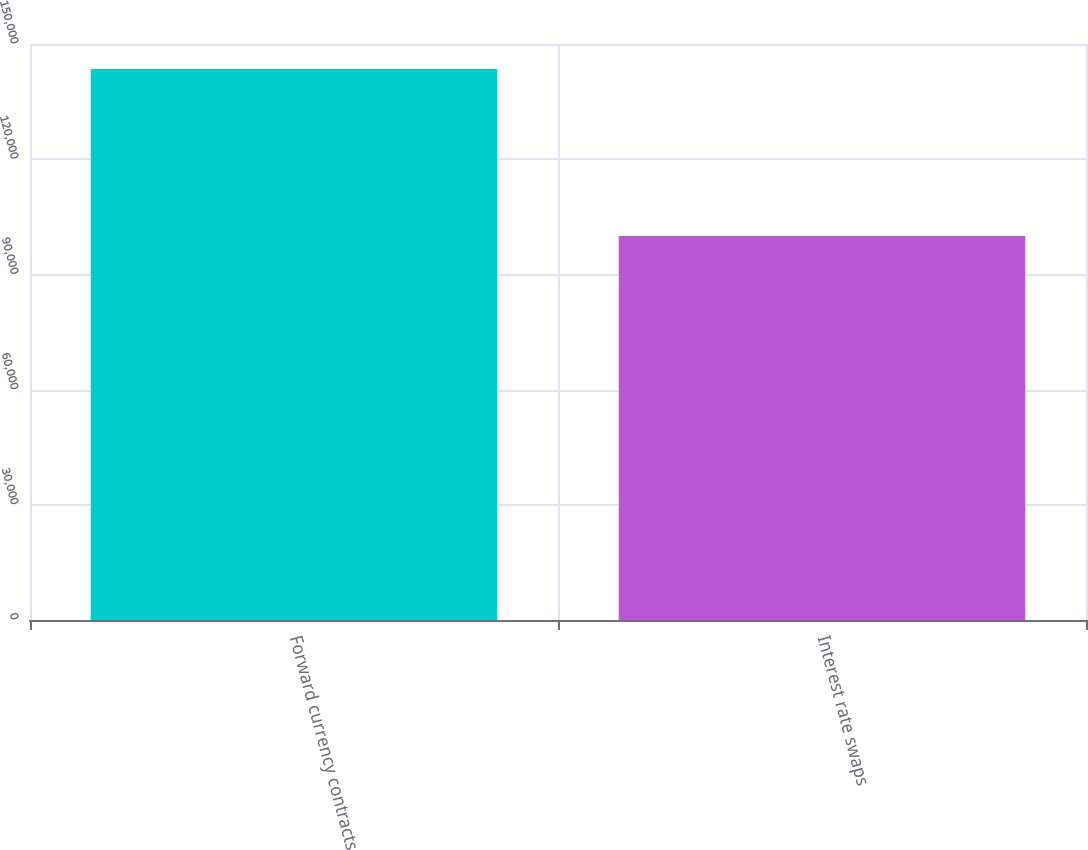<chart> <loc_0><loc_0><loc_500><loc_500><bar_chart><fcel>Forward currency contracts<fcel>Interest rate swaps<nl><fcel>143483<fcel>100000<nl></chart> 